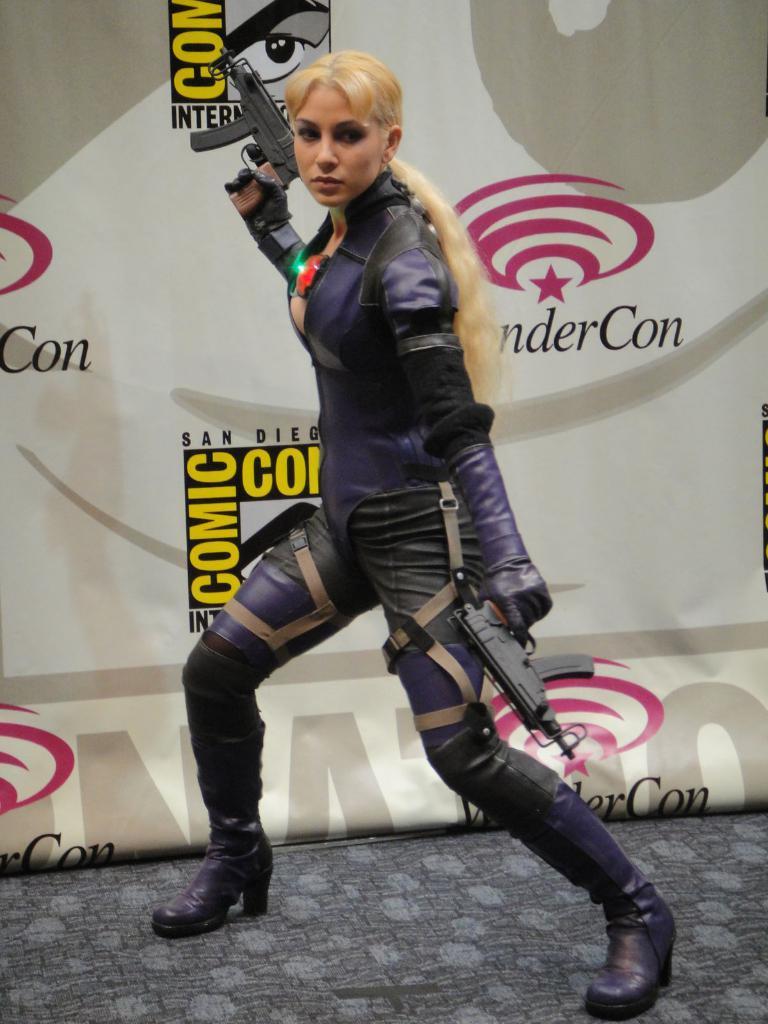How would you summarize this image in a sentence or two? In this image we can see a woman standing on the floor and holding guns in both of her hands. In the background there is an advertisement. 